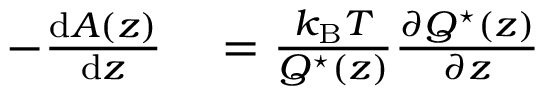Convert formula to latex. <formula><loc_0><loc_0><loc_500><loc_500>\begin{array} { r l } { - \frac { { d } A ( z ) } { { d } z } } & = \frac { k _ { B } T } { Q ^ { ^ { * } } ( z ) } \frac { \partial Q ^ { ^ { * } } ( z ) } { \partial z } } \end{array}</formula> 